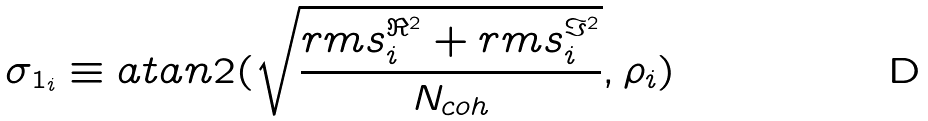Convert formula to latex. <formula><loc_0><loc_0><loc_500><loc_500>\sigma _ { 1 _ { i } } \equiv a t a n 2 ( \sqrt { \frac { r m s _ { i } ^ { \Re ^ { 2 } } + r m s _ { i } ^ { \Im ^ { 2 } } } { N _ { c o h } } } , \rho _ { i } )</formula> 